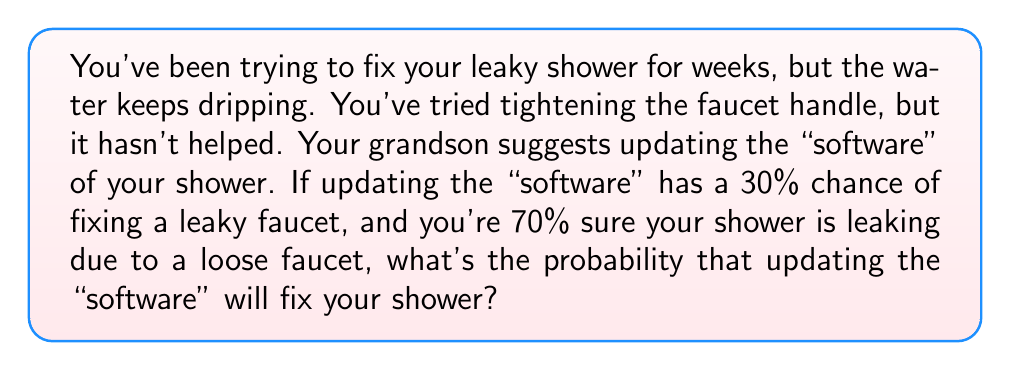Give your solution to this math problem. Let's approach this problem using Bayesian inference. We'll define our events as:

A: The shower is fixed by updating the "software"
B: The leak is due to a loose faucet

We're given:
P(A|B) = 0.30 (probability of fixing if it's a loose faucet)
P(B) = 0.70 (prior probability that it's a loose faucet)

We want to find P(A), the probability that updating the "software" will fix the shower.

Using the law of total probability:

$$P(A) = P(A|B)P(B) + P(A|\text{not }B)P(\text{not }B)$$

We know P(A|B) and P(B), but we need to estimate P(A|not B):
Let's assume updating the "software" has no effect if the problem isn't a loose faucet.
So, P(A|not B) = 0

Now we can calculate:

$$\begin{align*}
P(A) &= P(A|B)P(B) + P(A|\text{not }B)P(\text{not }B) \\
&= 0.30 \times 0.70 + 0 \times (1 - 0.70) \\
&= 0.21 + 0 \\
&= 0.21
\end{align*}$$

Therefore, the probability that updating the "software" will fix your shower is 0.21 or 21%.
Answer: 0.21 or 21% 